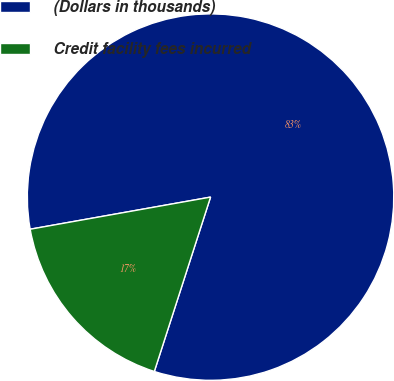Convert chart to OTSL. <chart><loc_0><loc_0><loc_500><loc_500><pie_chart><fcel>(Dollars in thousands)<fcel>Credit facility fees incurred<nl><fcel>82.77%<fcel>17.23%<nl></chart> 